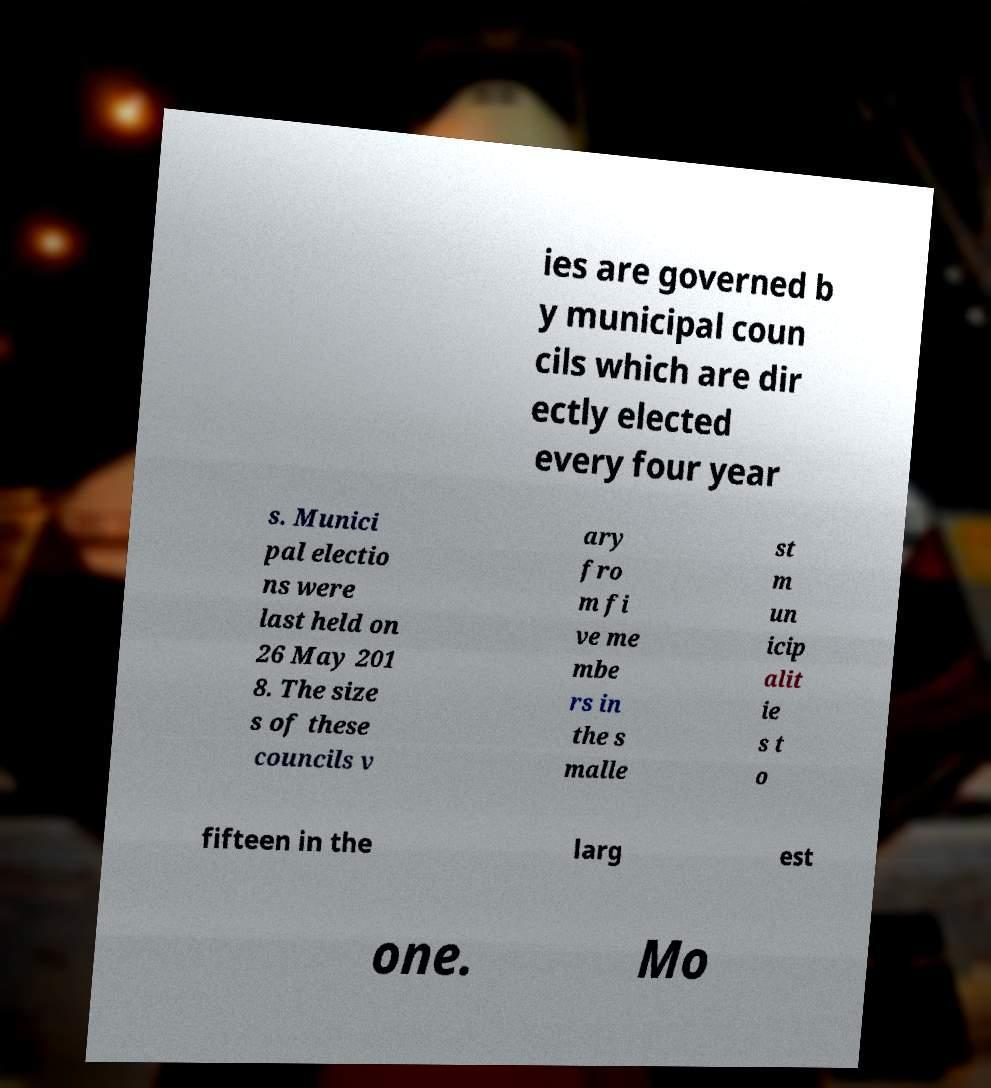Could you assist in decoding the text presented in this image and type it out clearly? ies are governed b y municipal coun cils which are dir ectly elected every four year s. Munici pal electio ns were last held on 26 May 201 8. The size s of these councils v ary fro m fi ve me mbe rs in the s malle st m un icip alit ie s t o fifteen in the larg est one. Mo 